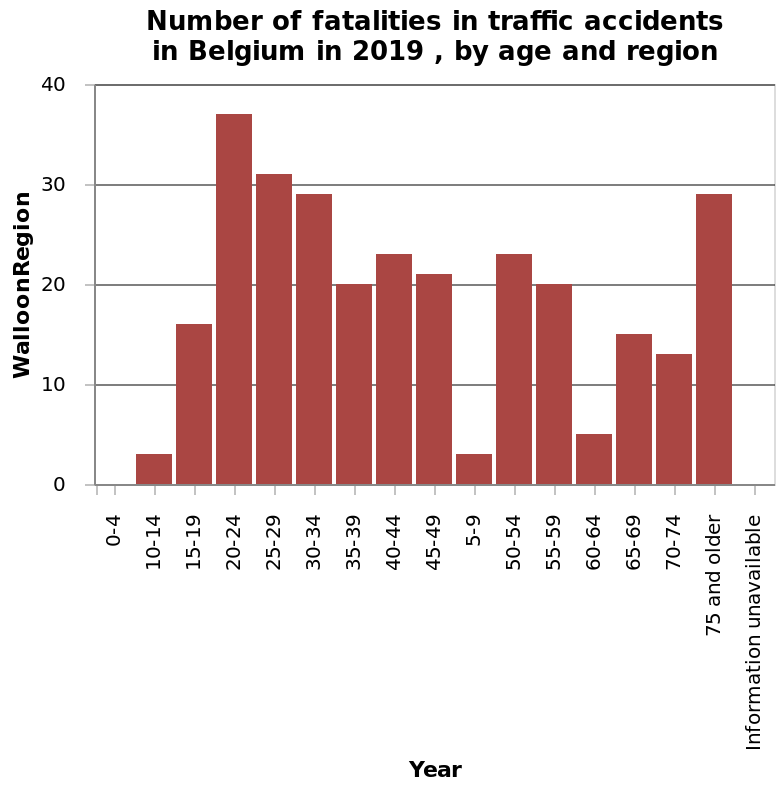<image>
Which age group has the highest fatality rate in crashes? 20-24-year-olds. In which age groups are children involved in crashes with the least fatalities? 10-14 & 5-9-year-olds. 